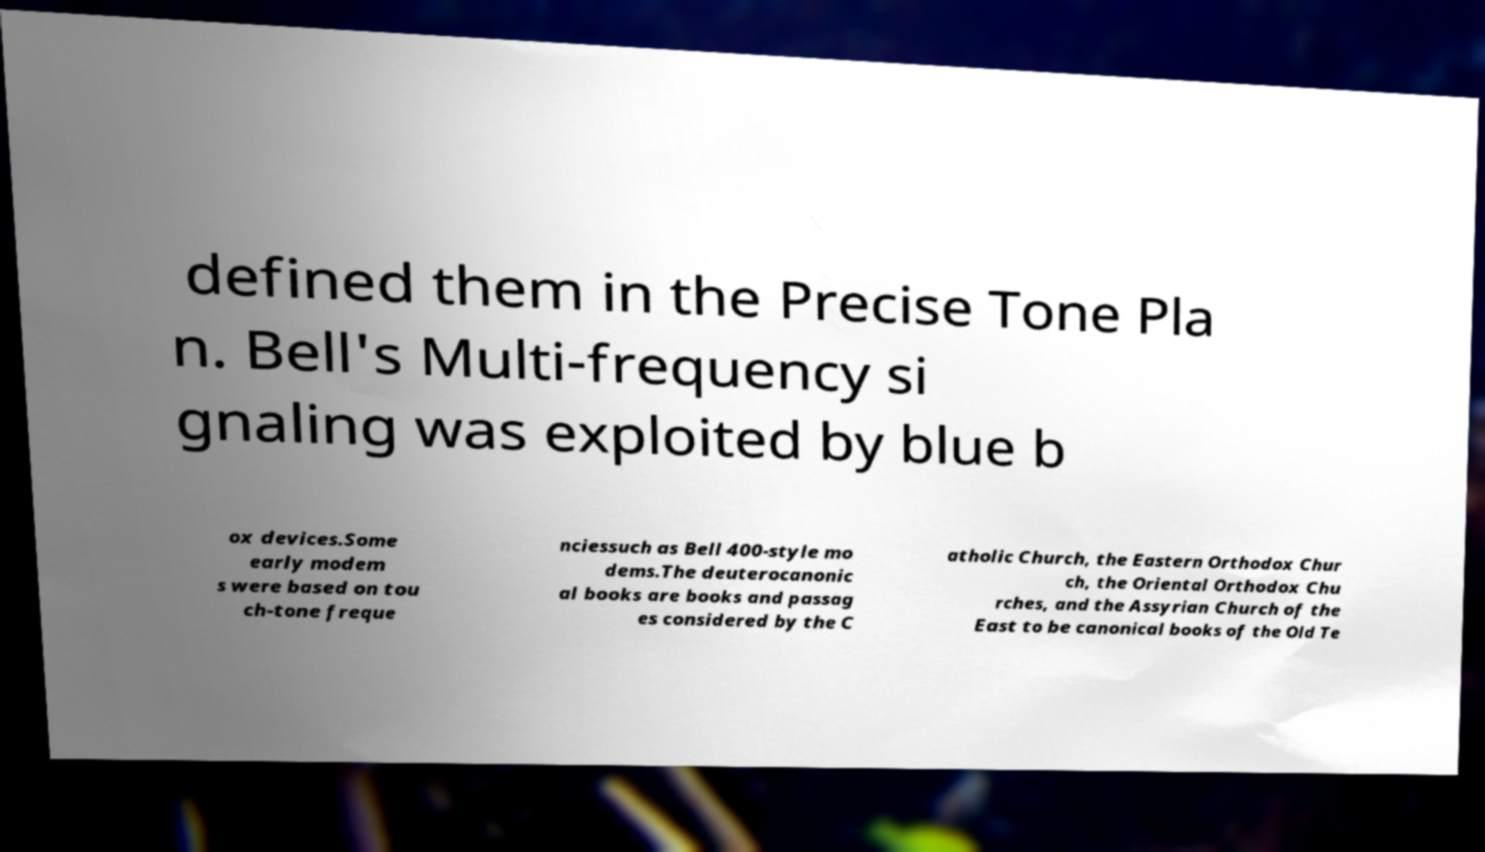What messages or text are displayed in this image? I need them in a readable, typed format. defined them in the Precise Tone Pla n. Bell's Multi-frequency si gnaling was exploited by blue b ox devices.Some early modem s were based on tou ch-tone freque nciessuch as Bell 400-style mo dems.The deuterocanonic al books are books and passag es considered by the C atholic Church, the Eastern Orthodox Chur ch, the Oriental Orthodox Chu rches, and the Assyrian Church of the East to be canonical books of the Old Te 